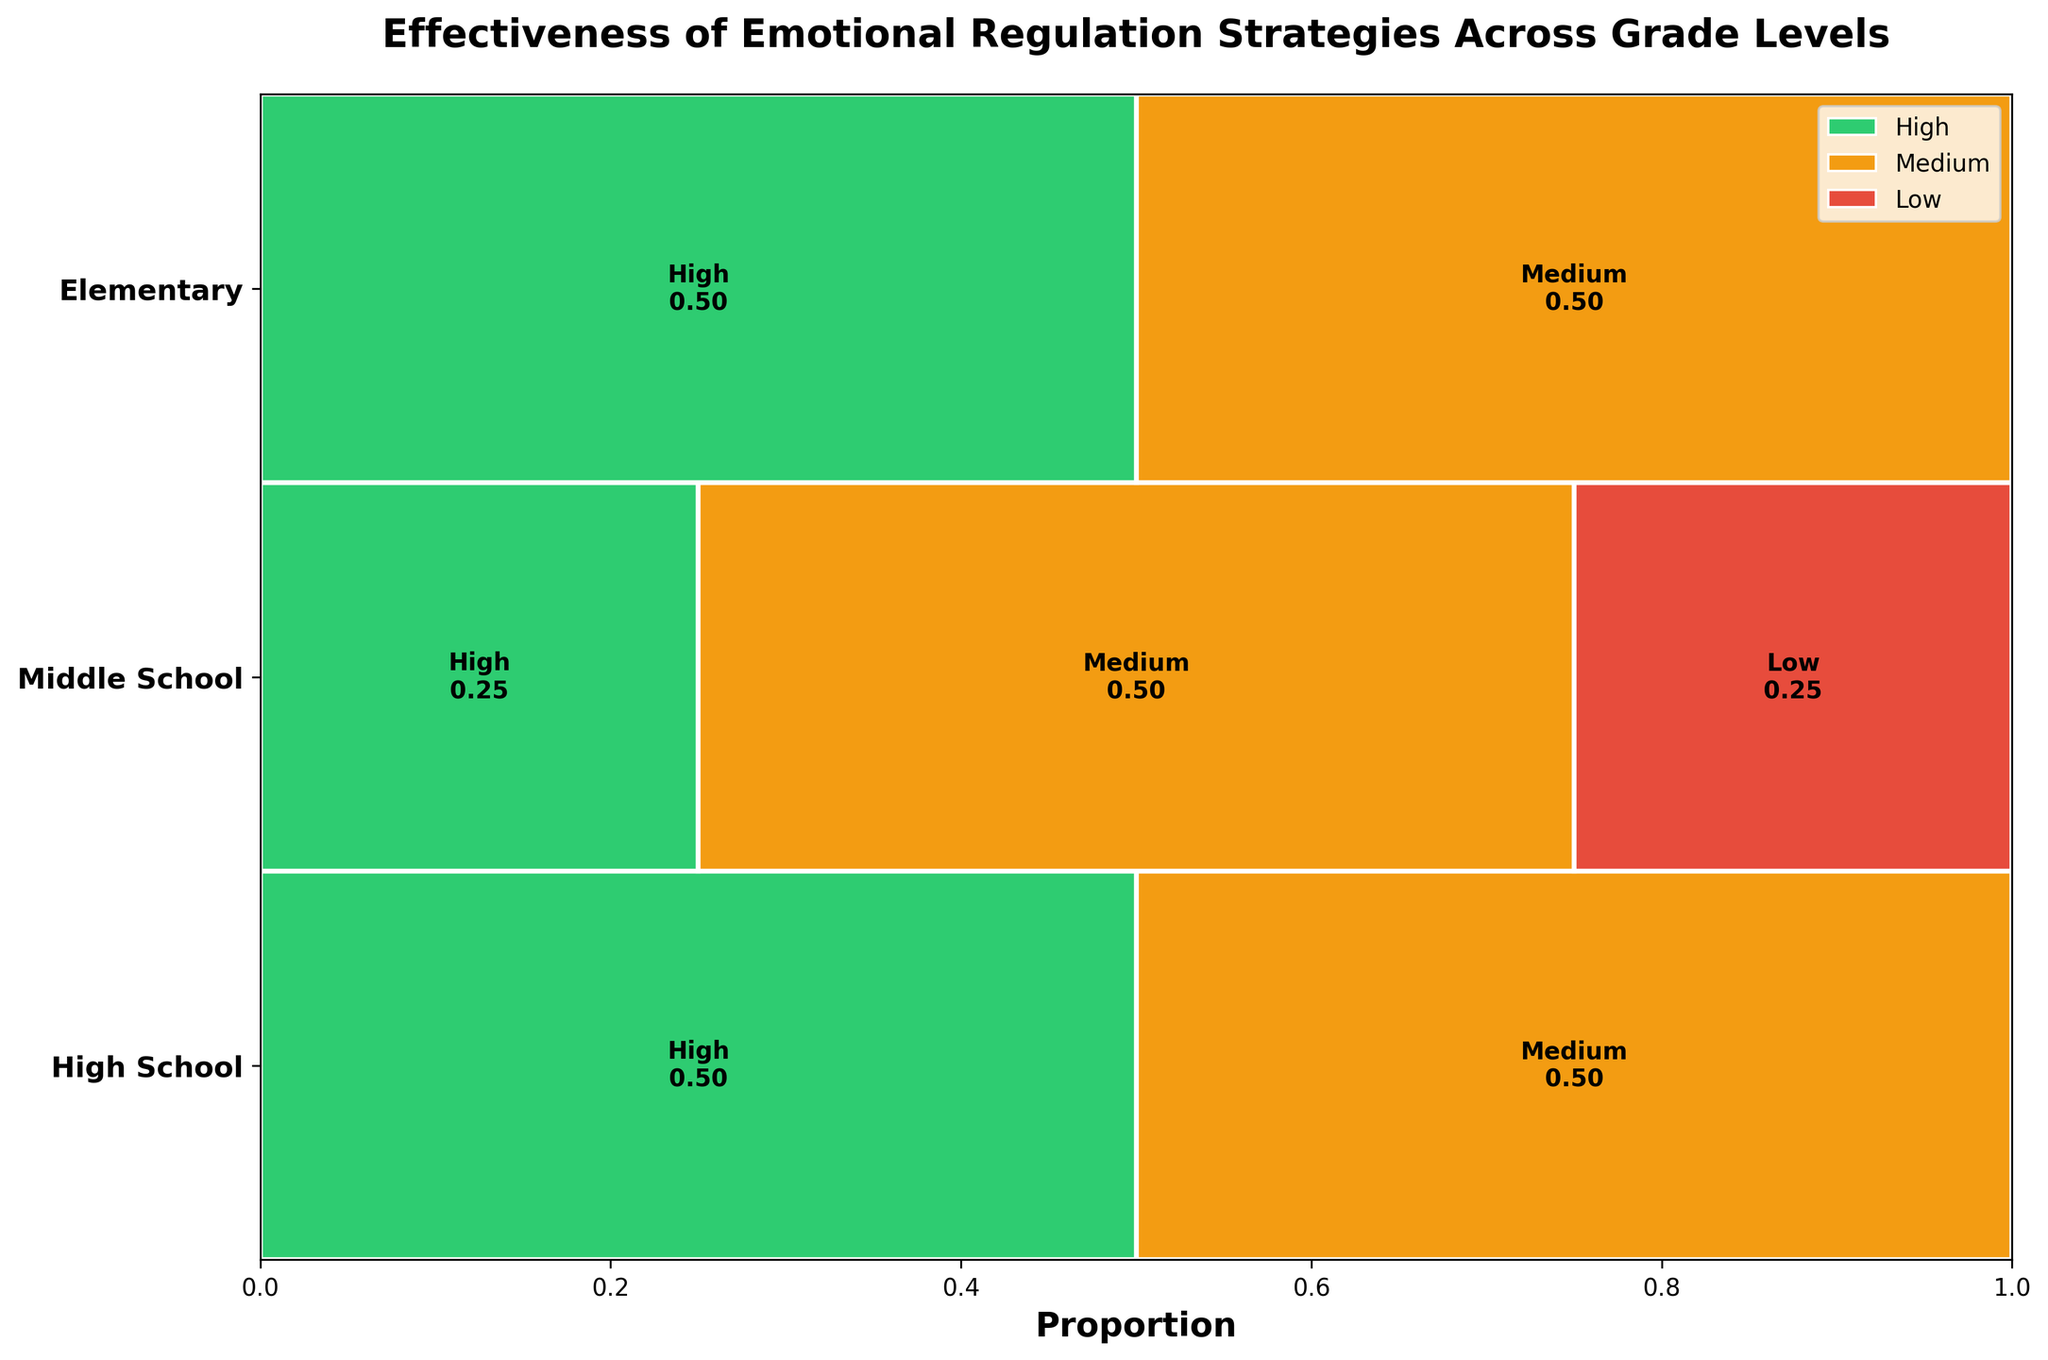What title is given to the plot? The title of the plot is usually displayed at the top. By looking at that area in the figure, you can find the title.
Answer: Effectiveness of Emotional Regulation Strategies Across Grade Levels Which grade level has the highest proportion of high effectiveness strategies? By examining the proportions of the "High" effectiveness strategies, represented by one specific color, you can determine which grade level has the highest proportion.
Answer: Middle School What is the proportion of medium effectiveness strategies in High School? Look for the segment corresponding to "Medium" in the High School row and read the proportion indicated within or near it.
Answer: 0.50 Between Elementary and Middle School, which grade level has a lower proportion of low effectiveness strategies? Identify the proportions of low effectiveness strategies for both Elementary and Middle School and compare them.
Answer: Middle School What is the total proportion of high and medium effectiveness strategies in Elementary School? Add the individual proportions for high and medium effectiveness strategies in the Elementary School row.
Answer: 0.75 How many effectiveness categories are represented in the plot? By counting the distinct categories of effectiveness represented by different colors or labels, you can find the total number.
Answer: 3 Does High School have any low effectiveness strategies represented? Quickly check the High School row to see if there is any segment or label for low effectiveness strategies.
Answer: No Compare the proportion of high effectiveness strategies between Elementary and High School. Which is higher? Examine the "High" effectiveness segments in both Elementary and High School rows and determine which one has a larger proportion.
Answer: High School What is the most common effectiveness category for Middle School strategies? Identify the largest segment within the Middle School row to determine the most common effectiveness category.
Answer: High Which grade level shows more diversity in the effectiveness of strategies, Elementary or High School? Look at the number of different effectiveness categories present and the variability in their proportions for both grade levels to determine which shows more diversity.
Answer: Elementary 